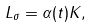<formula> <loc_0><loc_0><loc_500><loc_500>L _ { \sigma } = \alpha ( t ) K ,</formula> 